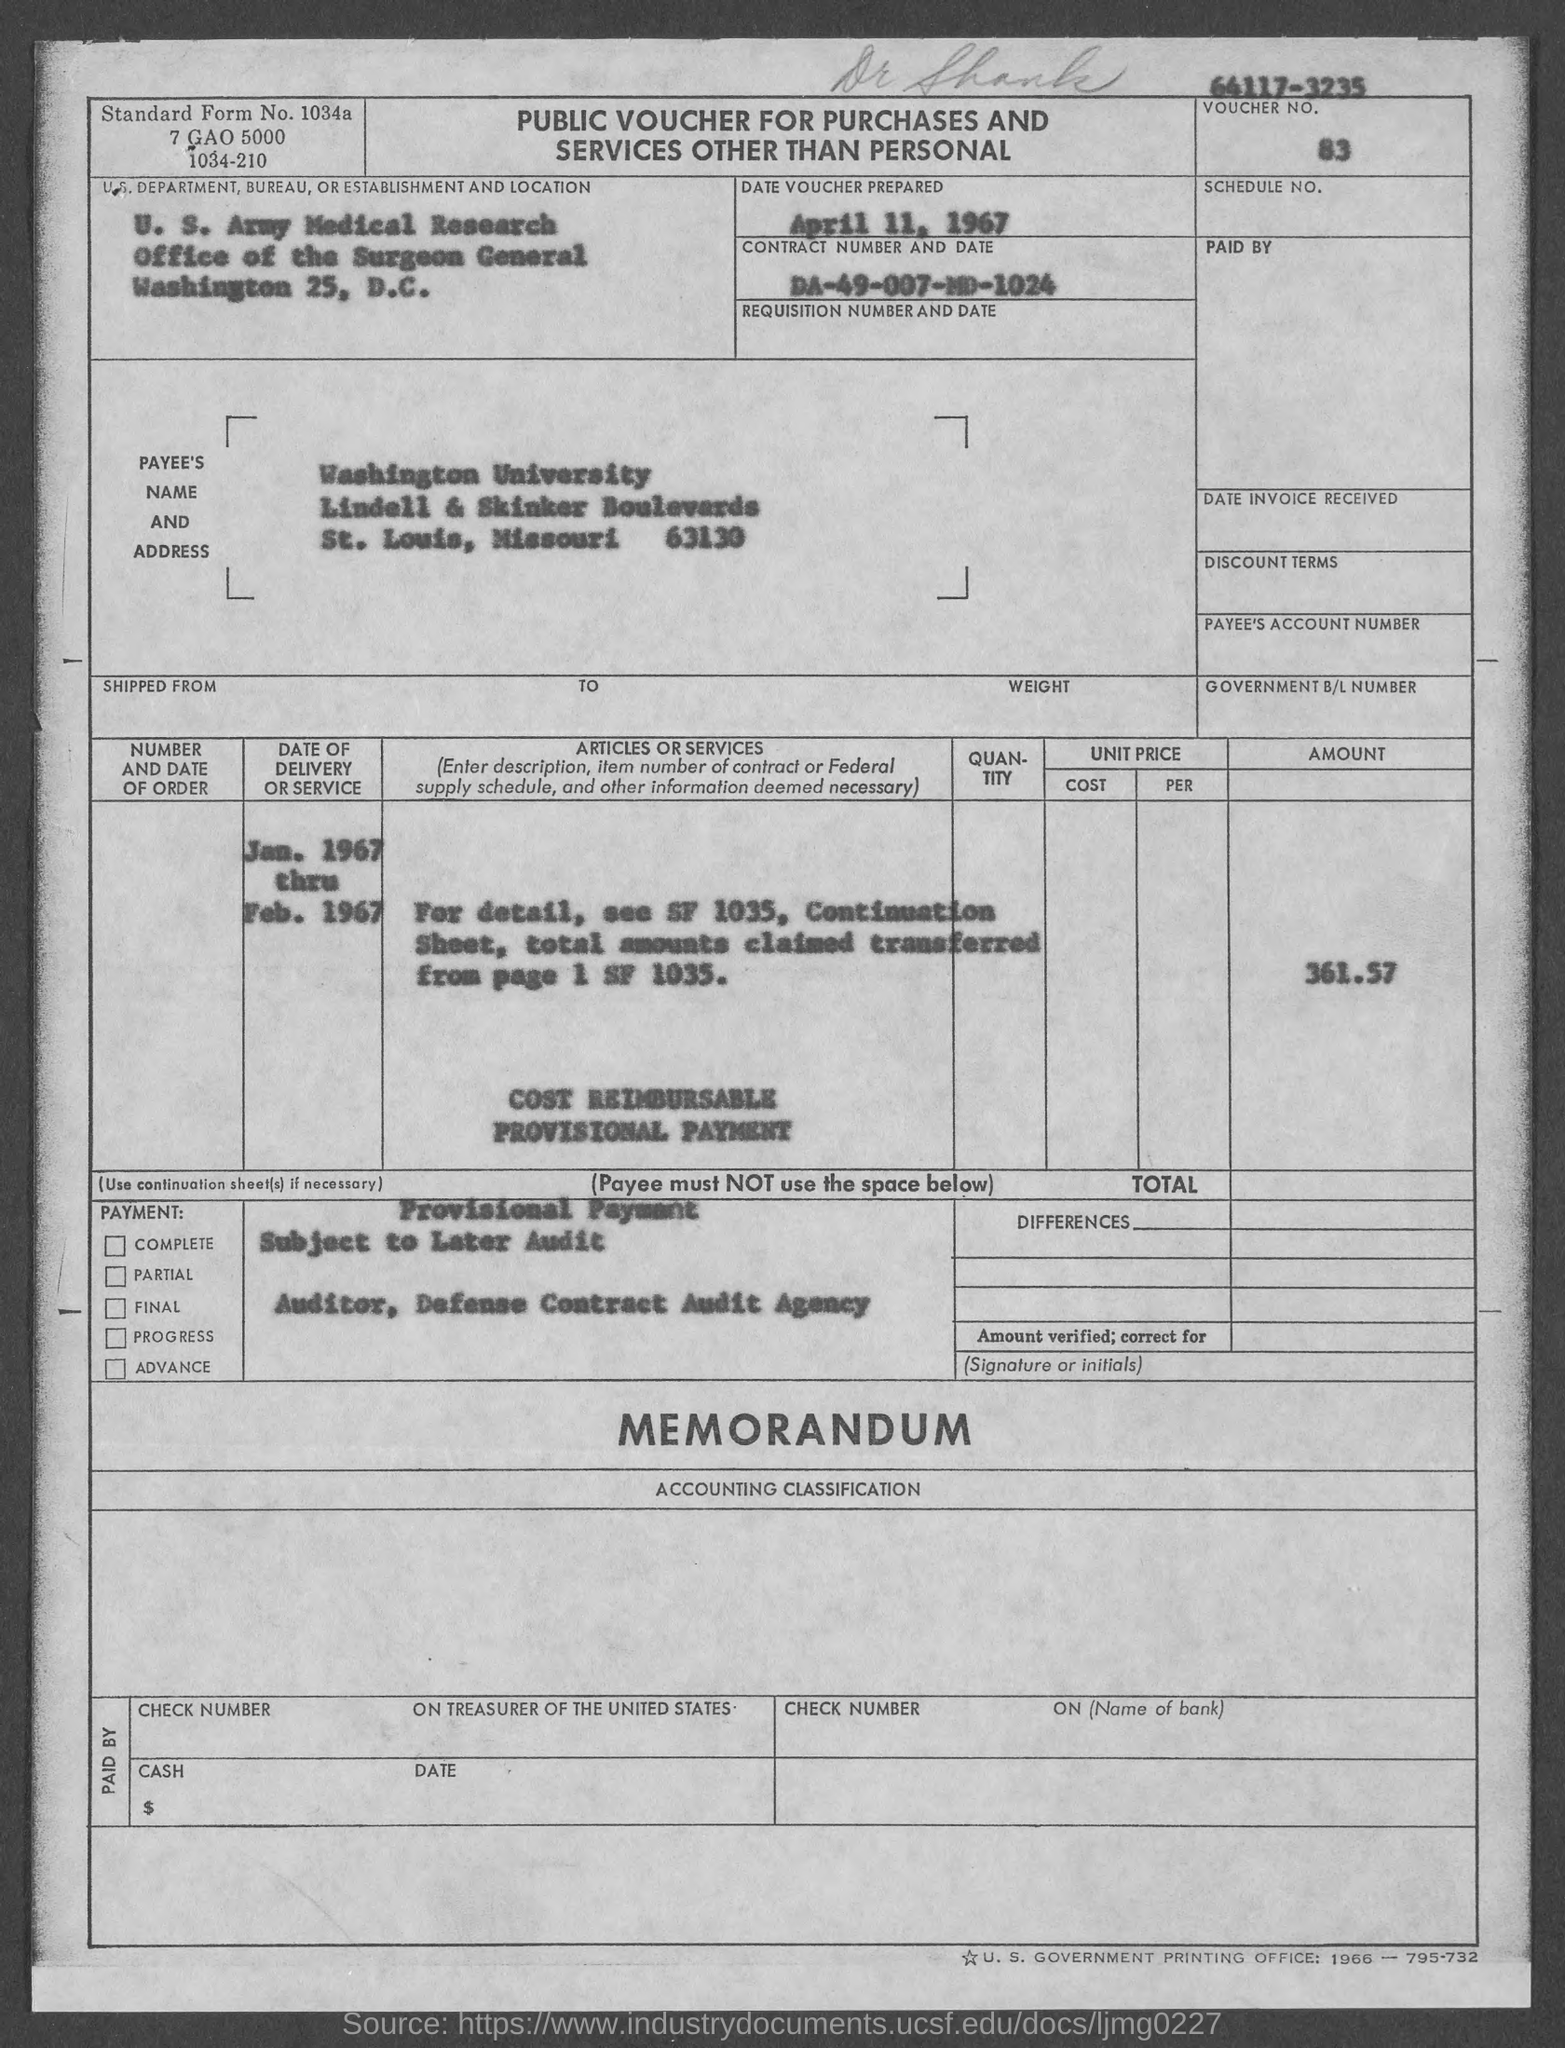Specify some key components in this picture. The contract number mentioned in the given form is DA-49-007-MD-1024. The voucher number mentioned in the provided form is 83. On what date was the voucher prepared, as mentioned in the given form? The date is April 11, 1967. The amount mentioned in the given form is 361.57... 